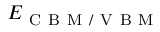<formula> <loc_0><loc_0><loc_500><loc_500>E _ { C B M / V B M }</formula> 